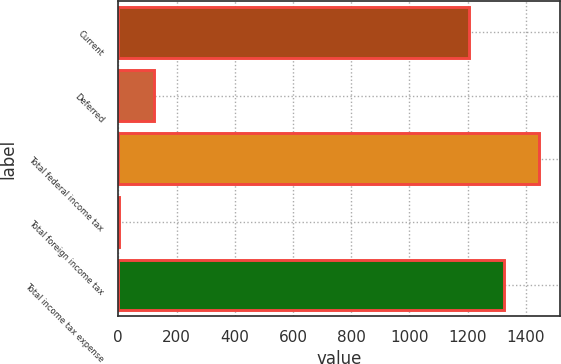Convert chart to OTSL. <chart><loc_0><loc_0><loc_500><loc_500><bar_chart><fcel>Current<fcel>Deferred<fcel>Total federal income tax<fcel>Total foreign income tax<fcel>Total income tax expense<nl><fcel>1204<fcel>122.5<fcel>1445<fcel>2<fcel>1324.5<nl></chart> 